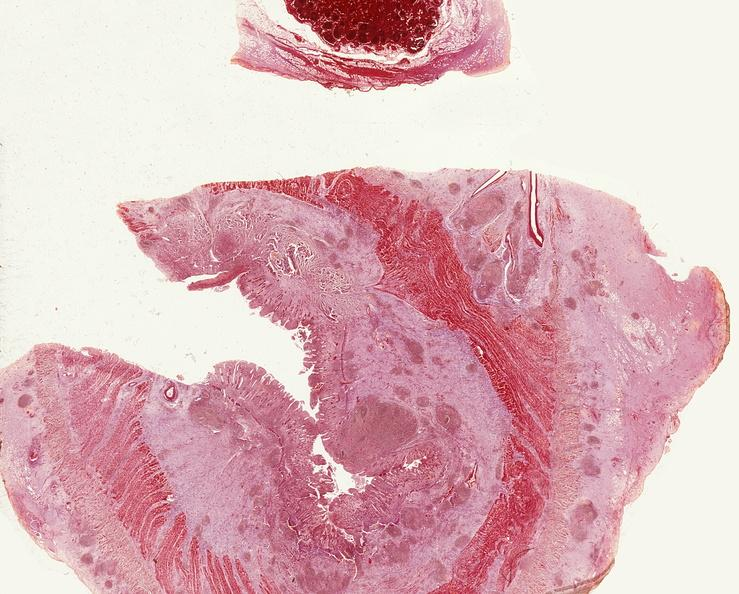s gastrointestinal present?
Answer the question using a single word or phrase. Yes 